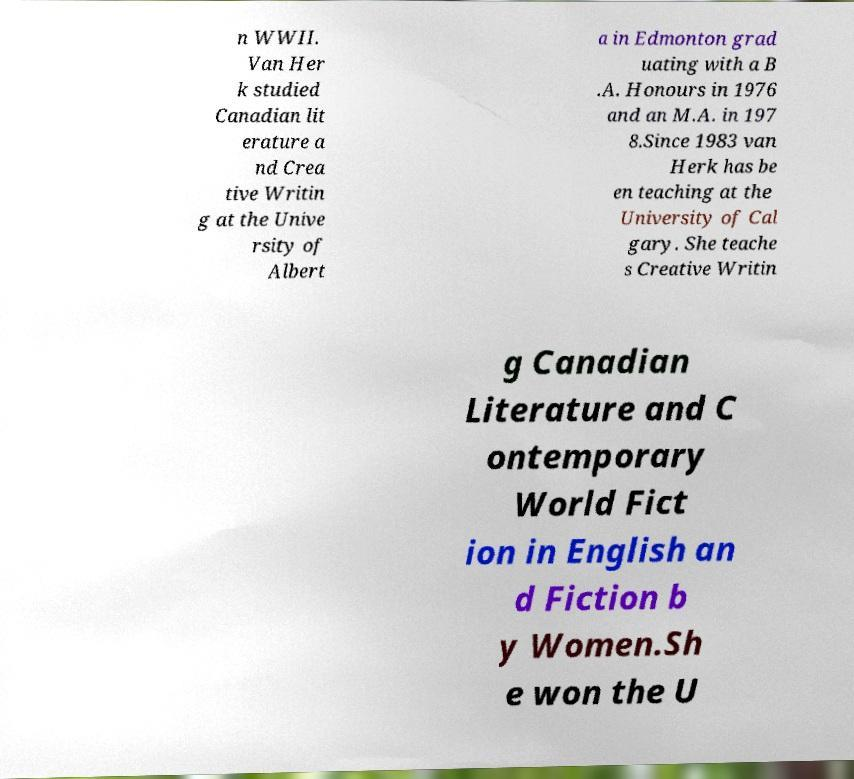Can you read and provide the text displayed in the image?This photo seems to have some interesting text. Can you extract and type it out for me? n WWII. Van Her k studied Canadian lit erature a nd Crea tive Writin g at the Unive rsity of Albert a in Edmonton grad uating with a B .A. Honours in 1976 and an M.A. in 197 8.Since 1983 van Herk has be en teaching at the University of Cal gary. She teache s Creative Writin g Canadian Literature and C ontemporary World Fict ion in English an d Fiction b y Women.Sh e won the U 